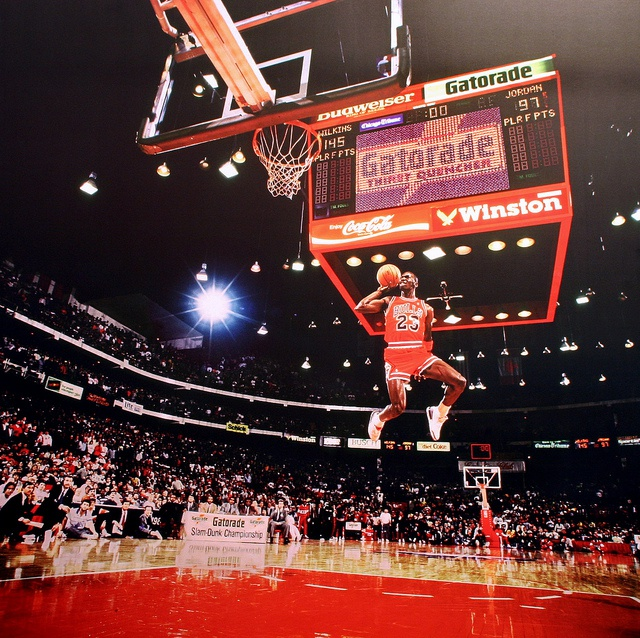Describe the objects in this image and their specific colors. I can see people in black, maroon, lightpink, and pink tones, people in black, white, red, maroon, and salmon tones, people in black, maroon, lightpink, and brown tones, people in black, maroon, brown, and pink tones, and people in black, lightgray, gray, and maroon tones in this image. 